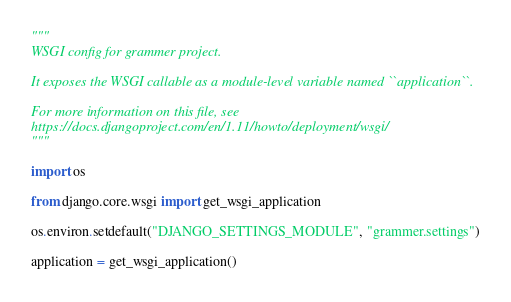Convert code to text. <code><loc_0><loc_0><loc_500><loc_500><_Python_>"""
WSGI config for grammer project.

It exposes the WSGI callable as a module-level variable named ``application``.

For more information on this file, see
https://docs.djangoproject.com/en/1.11/howto/deployment/wsgi/
"""

import os

from django.core.wsgi import get_wsgi_application

os.environ.setdefault("DJANGO_SETTINGS_MODULE", "grammer.settings")

application = get_wsgi_application()
</code> 